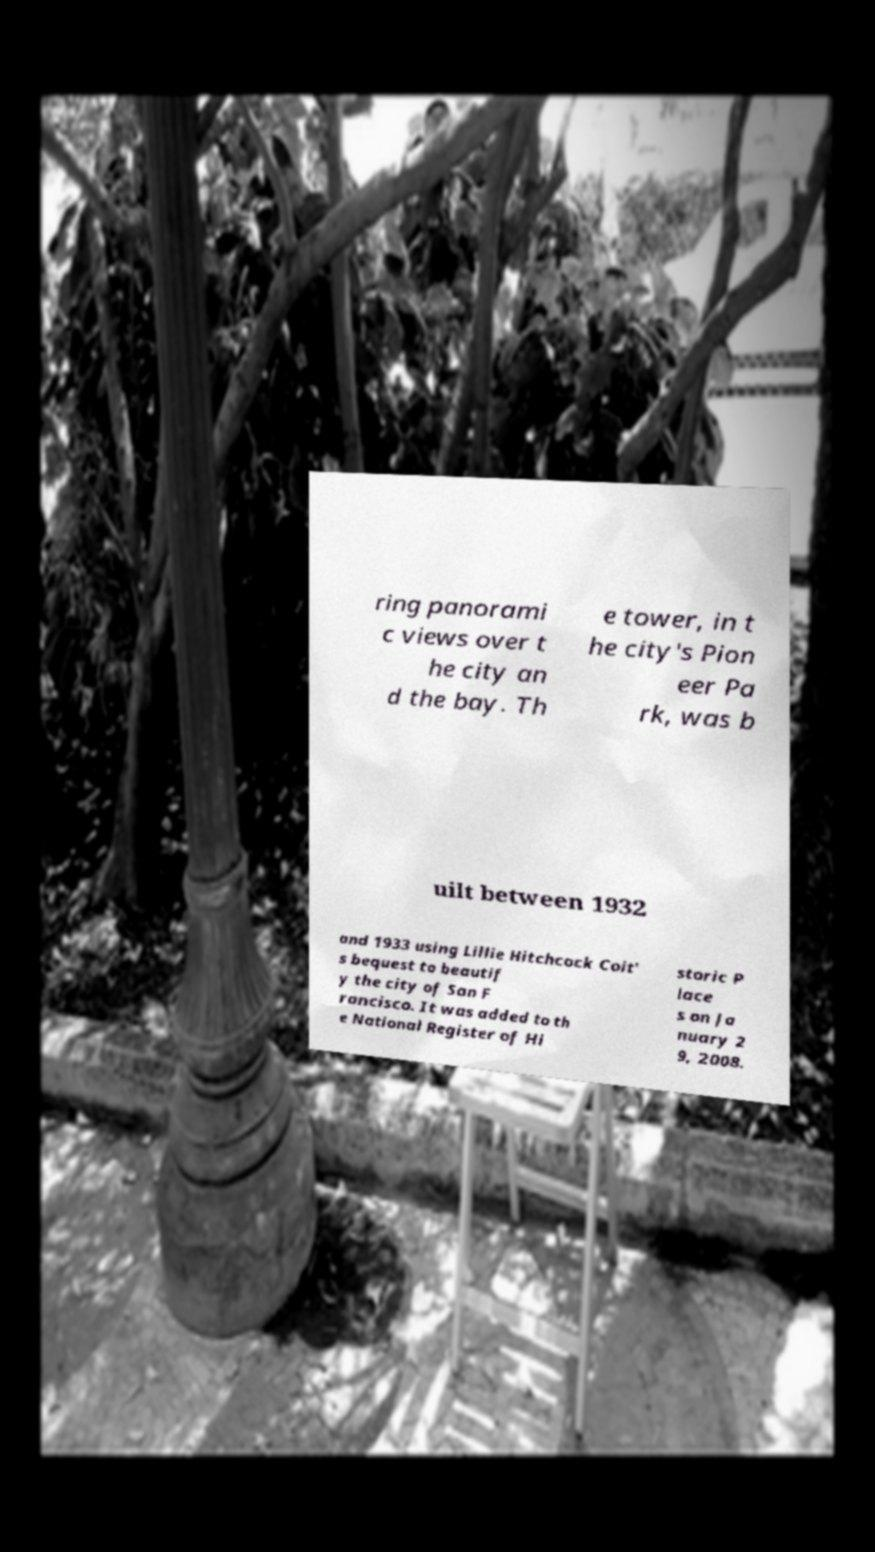There's text embedded in this image that I need extracted. Can you transcribe it verbatim? ring panorami c views over t he city an d the bay. Th e tower, in t he city's Pion eer Pa rk, was b uilt between 1932 and 1933 using Lillie Hitchcock Coit' s bequest to beautif y the city of San F rancisco. It was added to th e National Register of Hi storic P lace s on Ja nuary 2 9, 2008. 